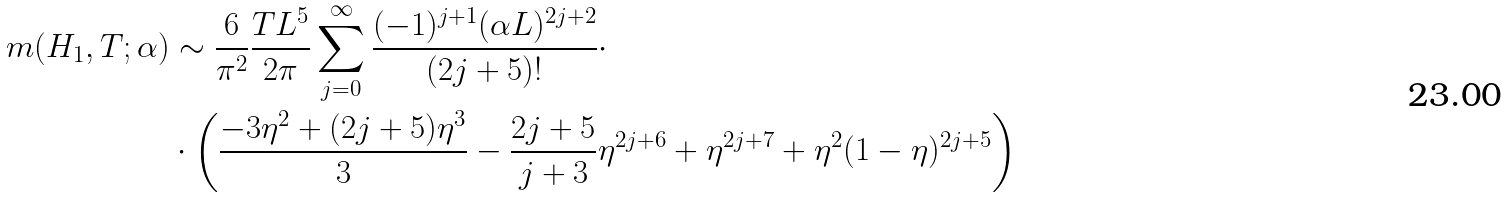Convert formula to latex. <formula><loc_0><loc_0><loc_500><loc_500>m ( H _ { 1 } , T ; \alpha ) & \sim \frac { 6 } { \pi ^ { 2 } } \frac { T L ^ { 5 } } { 2 \pi } \sum _ { j = 0 } ^ { \infty } \frac { ( - 1 ) ^ { j + 1 } ( \alpha L ) ^ { 2 j + 2 } } { ( 2 j + 5 ) ! } \cdot \\ & \cdot \left ( \frac { - 3 \eta ^ { 2 } + ( 2 j + 5 ) \eta ^ { 3 } } { 3 } - \frac { 2 j + 5 } { j + 3 } \eta ^ { 2 j + 6 } + \eta ^ { 2 j + 7 } + \eta ^ { 2 } ( 1 - \eta ) ^ { 2 j + 5 } \right ) \\</formula> 